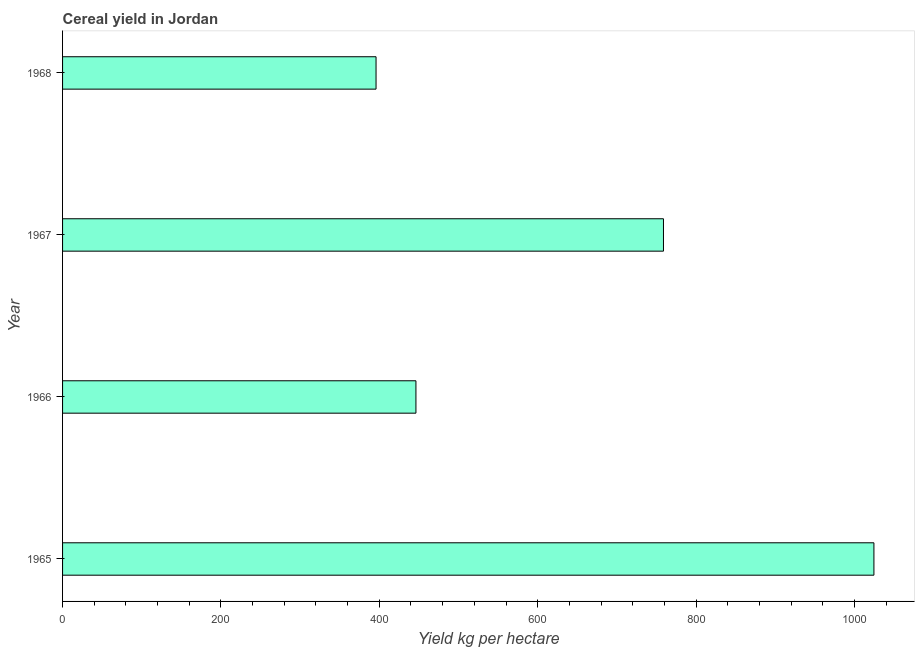Does the graph contain any zero values?
Keep it short and to the point. No. Does the graph contain grids?
Offer a very short reply. No. What is the title of the graph?
Your answer should be very brief. Cereal yield in Jordan. What is the label or title of the X-axis?
Ensure brevity in your answer.  Yield kg per hectare. What is the label or title of the Y-axis?
Provide a succinct answer. Year. What is the cereal yield in 1966?
Your answer should be compact. 446.26. Across all years, what is the maximum cereal yield?
Keep it short and to the point. 1024.62. Across all years, what is the minimum cereal yield?
Keep it short and to the point. 395.88. In which year was the cereal yield maximum?
Provide a succinct answer. 1965. In which year was the cereal yield minimum?
Offer a terse response. 1968. What is the sum of the cereal yield?
Offer a very short reply. 2625.61. What is the difference between the cereal yield in 1965 and 1966?
Offer a terse response. 578.36. What is the average cereal yield per year?
Offer a very short reply. 656.4. What is the median cereal yield?
Offer a very short reply. 602.55. Do a majority of the years between 1966 and 1967 (inclusive) have cereal yield greater than 920 kg per hectare?
Keep it short and to the point. No. What is the ratio of the cereal yield in 1965 to that in 1966?
Keep it short and to the point. 2.3. What is the difference between the highest and the second highest cereal yield?
Your response must be concise. 265.78. What is the difference between the highest and the lowest cereal yield?
Offer a terse response. 628.74. In how many years, is the cereal yield greater than the average cereal yield taken over all years?
Give a very brief answer. 2. Are all the bars in the graph horizontal?
Keep it short and to the point. Yes. What is the difference between two consecutive major ticks on the X-axis?
Your answer should be compact. 200. What is the Yield kg per hectare in 1965?
Provide a succinct answer. 1024.62. What is the Yield kg per hectare in 1966?
Provide a succinct answer. 446.26. What is the Yield kg per hectare of 1967?
Your answer should be very brief. 758.85. What is the Yield kg per hectare in 1968?
Ensure brevity in your answer.  395.88. What is the difference between the Yield kg per hectare in 1965 and 1966?
Give a very brief answer. 578.36. What is the difference between the Yield kg per hectare in 1965 and 1967?
Make the answer very short. 265.78. What is the difference between the Yield kg per hectare in 1965 and 1968?
Give a very brief answer. 628.74. What is the difference between the Yield kg per hectare in 1966 and 1967?
Offer a very short reply. -312.59. What is the difference between the Yield kg per hectare in 1966 and 1968?
Your response must be concise. 50.38. What is the difference between the Yield kg per hectare in 1967 and 1968?
Ensure brevity in your answer.  362.96. What is the ratio of the Yield kg per hectare in 1965 to that in 1966?
Your answer should be compact. 2.3. What is the ratio of the Yield kg per hectare in 1965 to that in 1967?
Your response must be concise. 1.35. What is the ratio of the Yield kg per hectare in 1965 to that in 1968?
Give a very brief answer. 2.59. What is the ratio of the Yield kg per hectare in 1966 to that in 1967?
Keep it short and to the point. 0.59. What is the ratio of the Yield kg per hectare in 1966 to that in 1968?
Keep it short and to the point. 1.13. What is the ratio of the Yield kg per hectare in 1967 to that in 1968?
Offer a terse response. 1.92. 